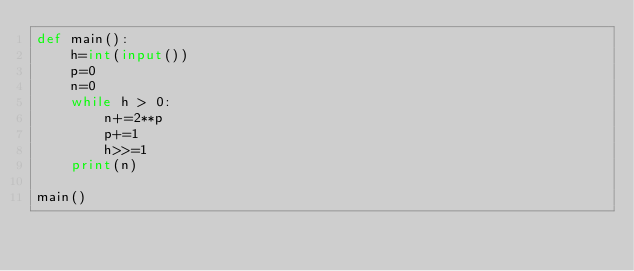Convert code to text. <code><loc_0><loc_0><loc_500><loc_500><_Python_>def main():
    h=int(input())
    p=0
    n=0
    while h > 0:
        n+=2**p
        p+=1
        h>>=1
    print(n)

main()</code> 